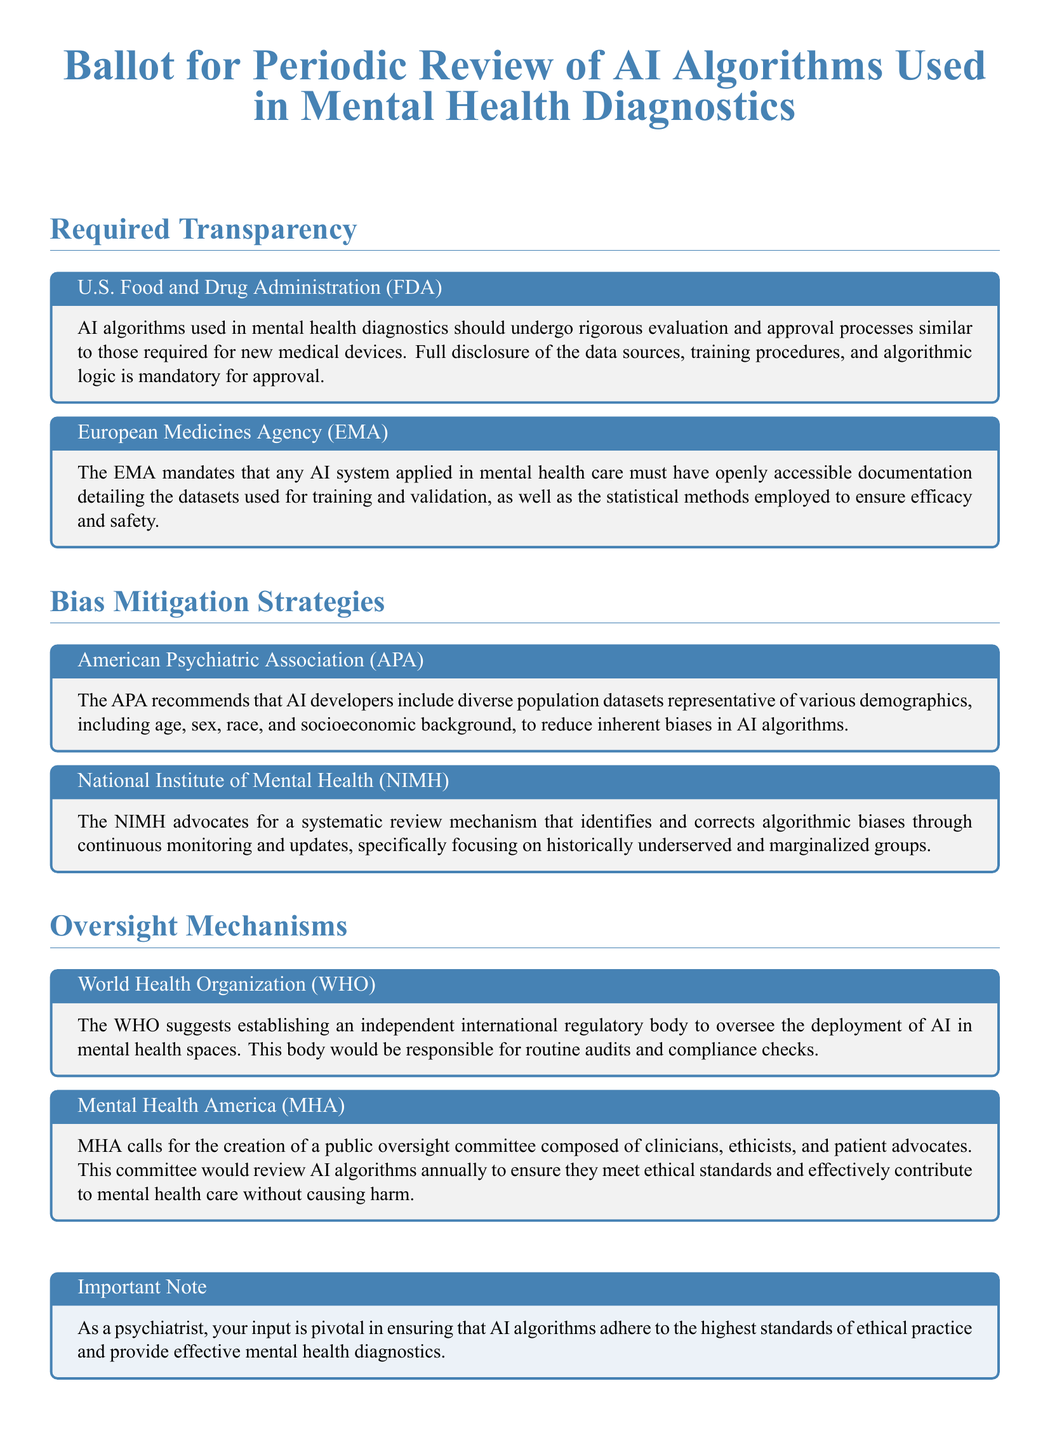What organization recommends including diverse population datasets in AI? The American Psychiatric Association (APA) recommends that AI developers include diverse population datasets to reduce inherent biases.
Answer: American Psychiatric Association (APA) What should AI algorithms undergo for approval according to the FDA? The AI algorithms used in mental health diagnostics should undergo rigorous evaluation and approval processes similar to those required for new medical devices.
Answer: Rigorous evaluation and approval processes What does NIMH advocate for in regards to algorithmic biases? The National Institute of Mental Health (NIMH) advocates for a systematic review mechanism that identifies and corrects algorithmic biases through continuous monitoring and updates.
Answer: Systematic review mechanism What is the frequency of reviews suggested by Mental Health America? Mental Health America (MHA) calls for the creation of a public oversight committee to review AI algorithms annually.
Answer: Annually What regulatory body does the WHO suggest establishing? The WHO suggests establishing an independent international regulatory body to oversee the deployment of AI in mental health spaces.
Answer: Independent international regulatory body What are the required elements for AI approval mentioned by the EMA? The European Medicines Agency (EMA) requires openly accessible documentation detailing the datasets used for training and validation, as well as the statistical methods employed.
Answer: Openly accessible documentation What is the purpose of the public oversight committee proposed by MHA? The committee would review AI algorithms annually to ensure they meet ethical standards and effectively contribute to mental health care without causing harm.
Answer: Ensure ethical standards and effectiveness What is included in the ballot's important note? The important note emphasizes that the input of psychiatrists is pivotal in ensuring AI algorithms adhere to ethical practices and provide effective mental health diagnostics.
Answer: Input is pivotal for ethical practice 